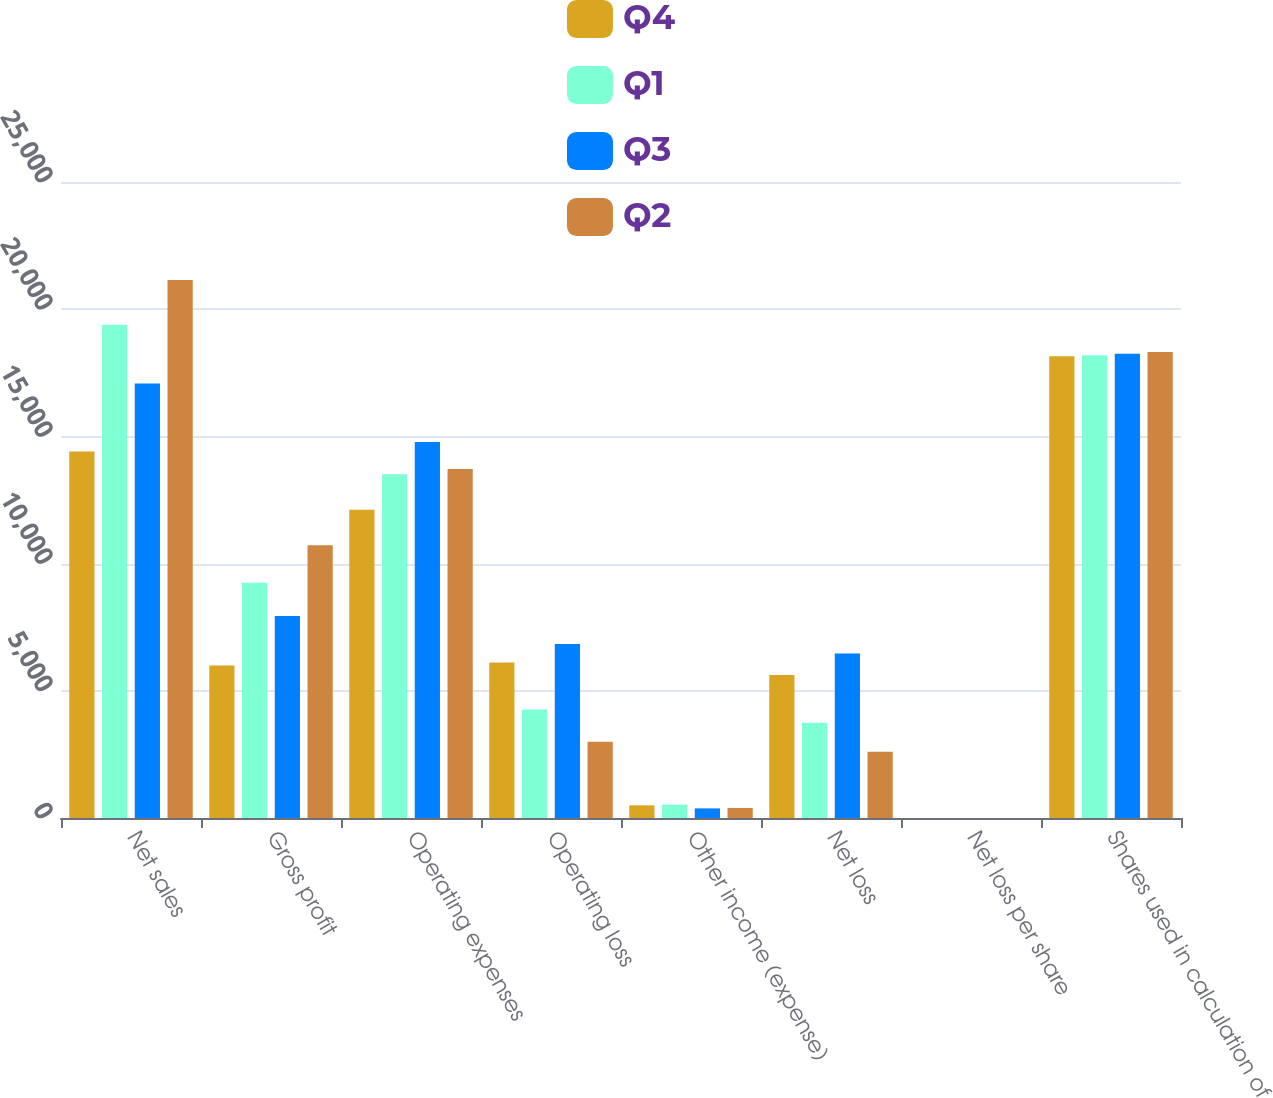<chart> <loc_0><loc_0><loc_500><loc_500><stacked_bar_chart><ecel><fcel>Net sales<fcel>Gross profit<fcel>Operating expenses<fcel>Operating loss<fcel>Other income (expense)<fcel>Net loss<fcel>Net loss per share<fcel>Shares used in calculation of<nl><fcel>Q4<fcel>14409<fcel>5998<fcel>12113<fcel>6115<fcel>498<fcel>5617<fcel>0.31<fcel>18154<nl><fcel>Q1<fcel>19387<fcel>9243<fcel>13510<fcel>4267<fcel>527<fcel>3740<fcel>0.21<fcel>18192<nl><fcel>Q3<fcel>17081<fcel>7938<fcel>14780<fcel>6842<fcel>378<fcel>6464<fcel>0.35<fcel>18250<nl><fcel>Q2<fcel>21145<fcel>10722<fcel>13717<fcel>2995<fcel>395<fcel>2600<fcel>0.14<fcel>18321<nl></chart> 